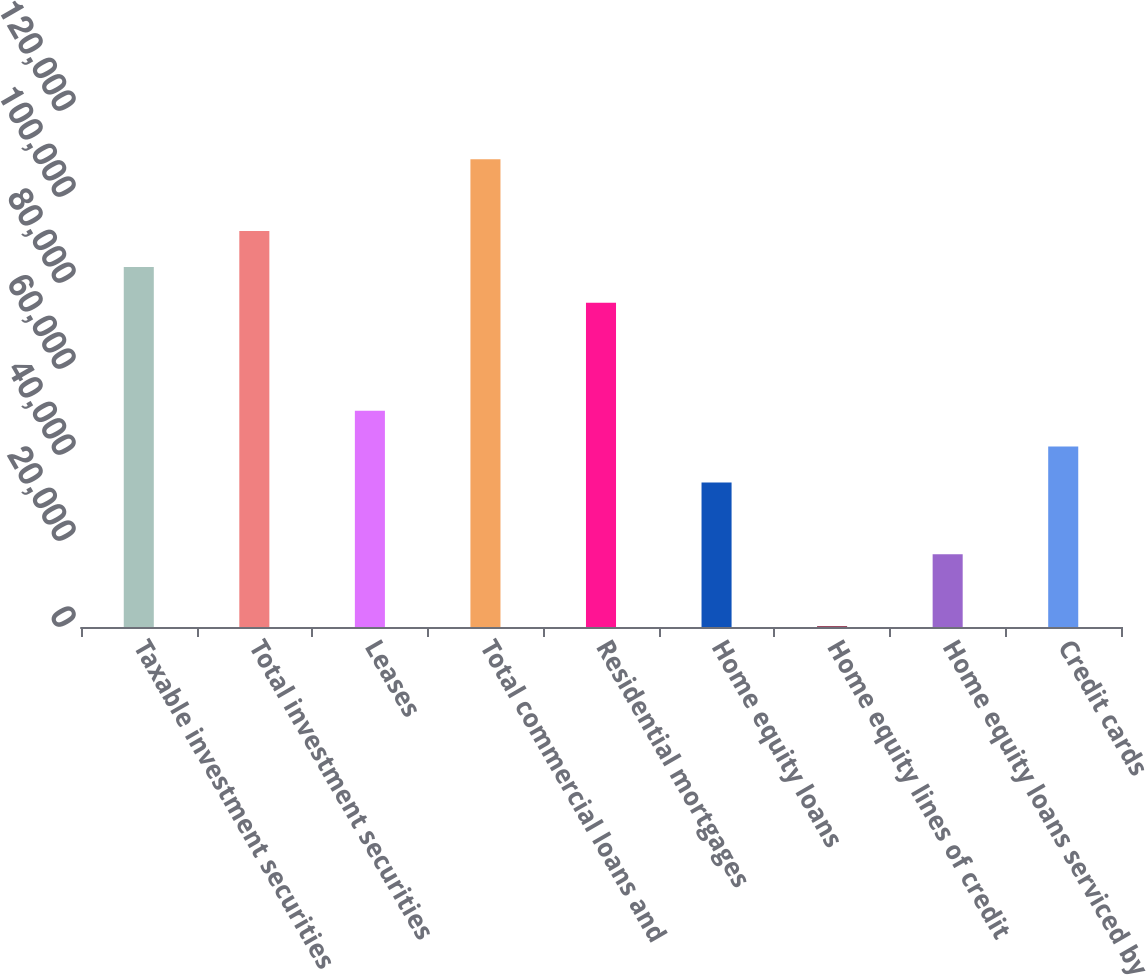<chart> <loc_0><loc_0><loc_500><loc_500><bar_chart><fcel>Taxable investment securities<fcel>Total investment securities<fcel>Leases<fcel>Total commercial loans and<fcel>Residential mortgages<fcel>Home equity loans<fcel>Home equity lines of credit<fcel>Home equity loans serviced by<fcel>Credit cards<nl><fcel>83740<fcel>92095.9<fcel>50316.4<fcel>108808<fcel>75384.1<fcel>33604.6<fcel>181<fcel>16892.8<fcel>41960.5<nl></chart> 